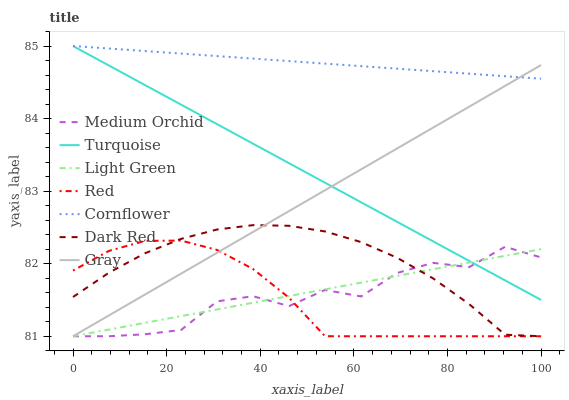Does Red have the minimum area under the curve?
Answer yes or no. Yes. Does Cornflower have the maximum area under the curve?
Answer yes or no. Yes. Does Turquoise have the minimum area under the curve?
Answer yes or no. No. Does Turquoise have the maximum area under the curve?
Answer yes or no. No. Is Turquoise the smoothest?
Answer yes or no. Yes. Is Medium Orchid the roughest?
Answer yes or no. Yes. Is Gray the smoothest?
Answer yes or no. No. Is Gray the roughest?
Answer yes or no. No. Does Turquoise have the lowest value?
Answer yes or no. No. Does Turquoise have the highest value?
Answer yes or no. Yes. Does Gray have the highest value?
Answer yes or no. No. Is Medium Orchid less than Cornflower?
Answer yes or no. Yes. Is Cornflower greater than Dark Red?
Answer yes or no. Yes. Does Dark Red intersect Medium Orchid?
Answer yes or no. Yes. Is Dark Red less than Medium Orchid?
Answer yes or no. No. Is Dark Red greater than Medium Orchid?
Answer yes or no. No. Does Medium Orchid intersect Cornflower?
Answer yes or no. No. 